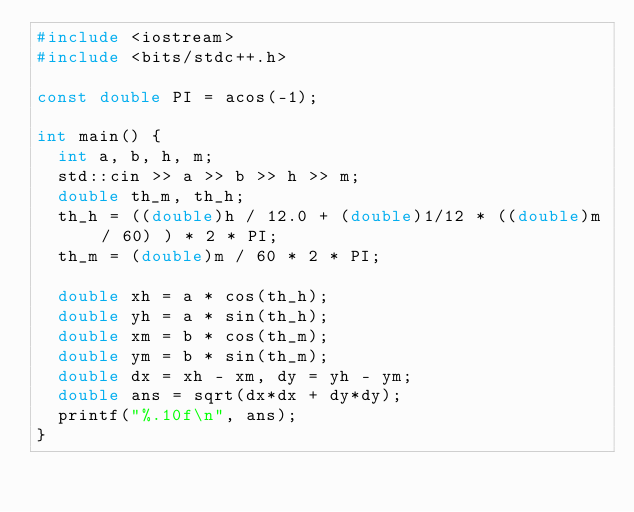<code> <loc_0><loc_0><loc_500><loc_500><_C++_>#include <iostream>
#include <bits/stdc++.h>

const double PI = acos(-1);

int main() {
  int a, b, h, m;
  std::cin >> a >> b >> h >> m;
  double th_m, th_h;
  th_h = ((double)h / 12.0 + (double)1/12 * ((double)m / 60) ) * 2 * PI;
  th_m = (double)m / 60 * 2 * PI;
  
  double xh = a * cos(th_h);
  double yh = a * sin(th_h);
  double xm = b * cos(th_m);
  double ym = b * sin(th_m);
  double dx = xh - xm, dy = yh - ym;
  double ans = sqrt(dx*dx + dy*dy);
  printf("%.10f\n", ans);
}
</code> 